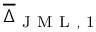Convert formula to latex. <formula><loc_0><loc_0><loc_500><loc_500>\overline { \Delta } _ { J M L , 1 }</formula> 